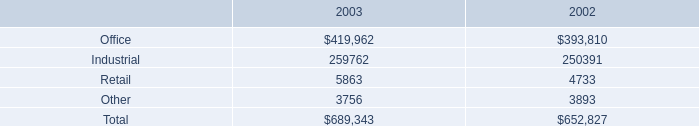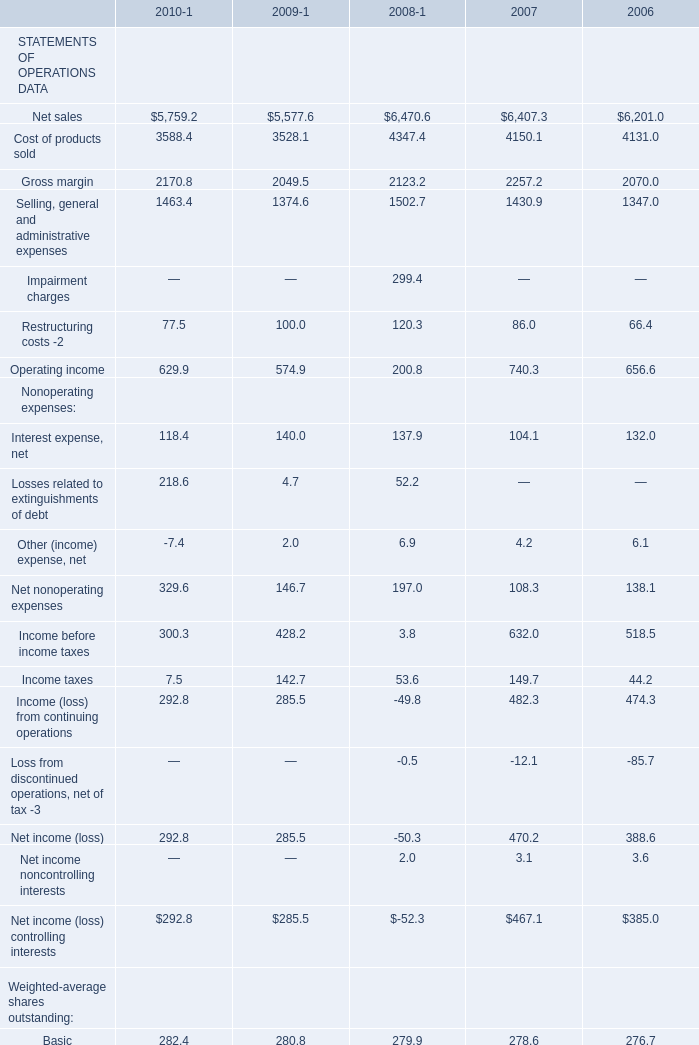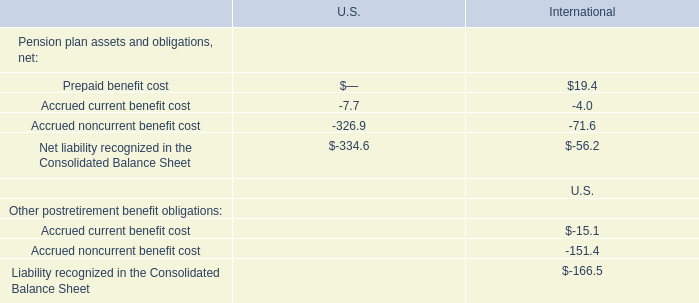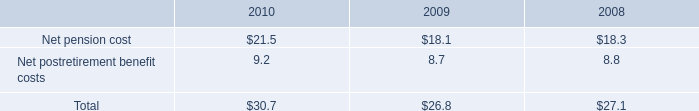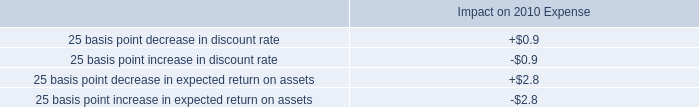what was the total of impairment charges associated with contracts to sell land parcels for the years ended december 31 , 2004 and 2003 , respectively . 
Computations: (424000 + 560000)
Answer: 984000.0. 